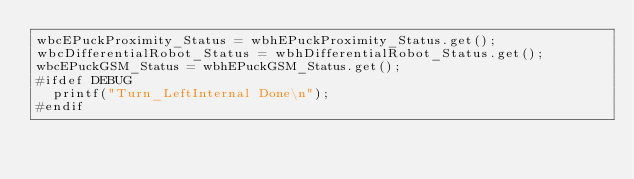<code> <loc_0><loc_0><loc_500><loc_500><_ObjectiveC_>wbcEPuckProximity_Status = wbhEPuckProximity_Status.get();
wbcDifferentialRobot_Status = wbhDifferentialRobot_Status.get();
wbcEPuckGSM_Status = wbhEPuckGSM_Status.get();
#ifdef DEBUG
  printf("Turn_LeftInternal Done\n");
#endif
</code> 